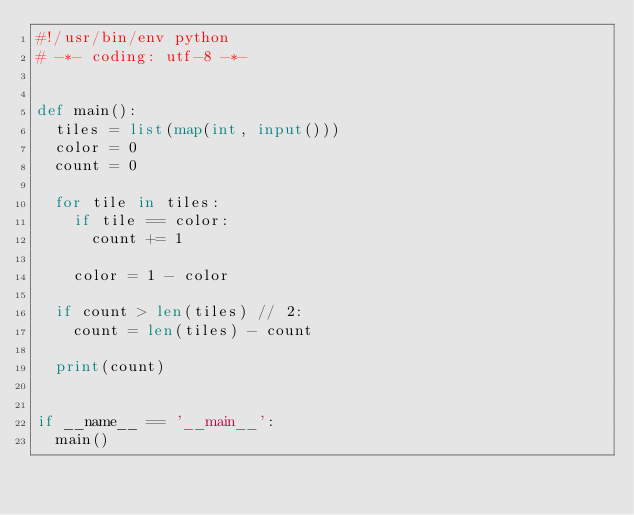<code> <loc_0><loc_0><loc_500><loc_500><_Python_>#!/usr/bin/env python
# -*- coding: utf-8 -*-


def main():
  tiles = list(map(int, input()))
  color = 0
  count = 0

  for tile in tiles:
    if tile == color:
      count += 1

    color = 1 - color

  if count > len(tiles) // 2:
    count = len(tiles) - count

  print(count)


if __name__ == '__main__':
  main()

</code> 